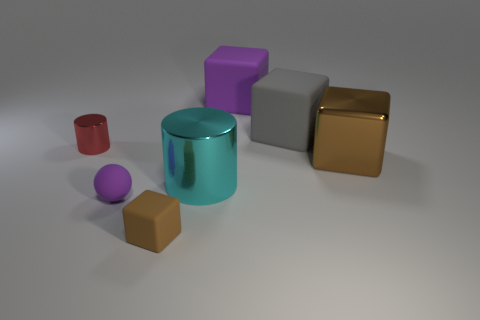There is a cube that is the same color as the ball; what is it made of?
Make the answer very short. Rubber. What color is the rubber cube that is in front of the brown cube right of the large cyan object?
Your response must be concise. Brown. Is the brown metallic cube the same size as the gray block?
Make the answer very short. Yes. There is another large brown thing that is the same shape as the brown matte object; what material is it?
Your answer should be very brief. Metal. How many brown metallic cubes have the same size as the purple cube?
Your answer should be compact. 1. What is the color of the block that is made of the same material as the tiny red object?
Make the answer very short. Brown. Is the number of small cubes less than the number of big brown rubber spheres?
Ensure brevity in your answer.  No. What number of gray things are either big things or big shiny things?
Your answer should be very brief. 1. How many things are both in front of the small ball and behind the gray matte block?
Your answer should be compact. 0. Is the material of the purple cube the same as the large brown thing?
Offer a terse response. No. 